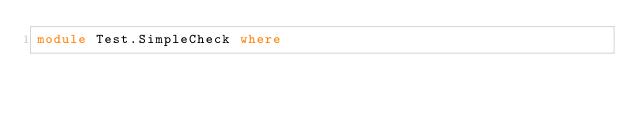<code> <loc_0><loc_0><loc_500><loc_500><_Haskell_>module Test.SimpleCheck where

</code> 